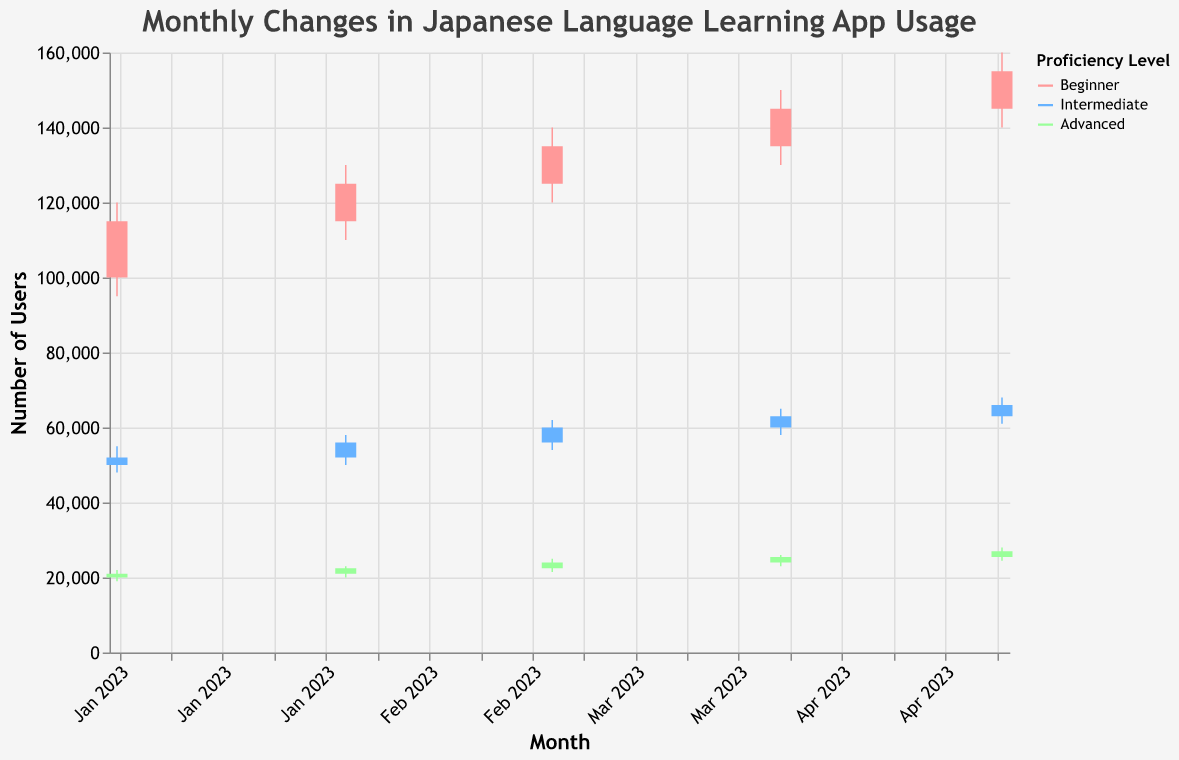How many proficiency levels are represented in the chart? The color legend shows three colors each representing a proficiency level. These levels are: Beginner, Intermediate, and Advanced.
Answer: Three In which month did the number of Advanced users peak? The 'High' value shows the highest number of users for each month. For Advanced users, the highest value is 28000, which occurred in May 2023.
Answer: May 2023 Which proficiency level has the highest overall number of users in April 2023? Look at the 'High' values for April 2023 for all proficiency levels. Beginner has a 'High' of 150000, Intermediate has 65000, and Advanced has 26000. The highest overall is for Beginner.
Answer: Beginner What was the closing number of Beginner users in March 2023? Find the 'Close' value for Beginner users in March 2023, which is 135000.
Answer: 135000 By how much did the closing number of Intermediate users increase from April 2023 to May 2023? Find the 'Close' values for Intermediate users for April (63000) and May (66000). Calculate the difference: 66000 - 63000 = 3000.
Answer: 3000 Compare the opening number of Beginner users between February 2023 and March 2023. Which month had more? Look at the 'Open' values for Beginner users in February (115000) and March (125000). March had more users: 125000 > 115000.
Answer: March 2023 What is the average 'High' number of users for Advanced proficiency over the given months? Sum the 'High' values for Advanced users (22000, 23000, 25000, 26000, 28000) and divide by the number of months (5). The sum is 124000, and the average is 124000 / 5 = 24800.
Answer: 24800 Which proficiency level experienced the smallest range (High - Low) in January 2023? Calculate the range for each proficiency level in January 2023: 
- Beginner: 120000 - 95000 = 25000 
- Intermediate: 55000 - 48000 = 7000 
- Advanced: 22000 - 19000 = 3000
The smallest range is for Advanced, which is 3000.
Answer: Advanced Which proficiency level saw the most consistent growth in the number of users over the months? Look at the consistent increase in 'Close' values over the months for all proficiency levels:
- Beginner: 115000, 125000, 135000, 145000, 155000 (consistent increase)
- Intermediate: 52000, 56000, 60000, 63000, 66000 (consistent increase)
- Advanced: 21000, 22500, 24000, 25500, 27000 (consistent increase)
All proficiency levels show consistent growth.
Answer: All levels What is the difference in the high number of Beginner users between March 2023 and May 2023? Find the 'High' values for Beginner users in March (140000) and May (160000). Calculate the difference: 160000 - 140000 = 20000.
Answer: 20000 